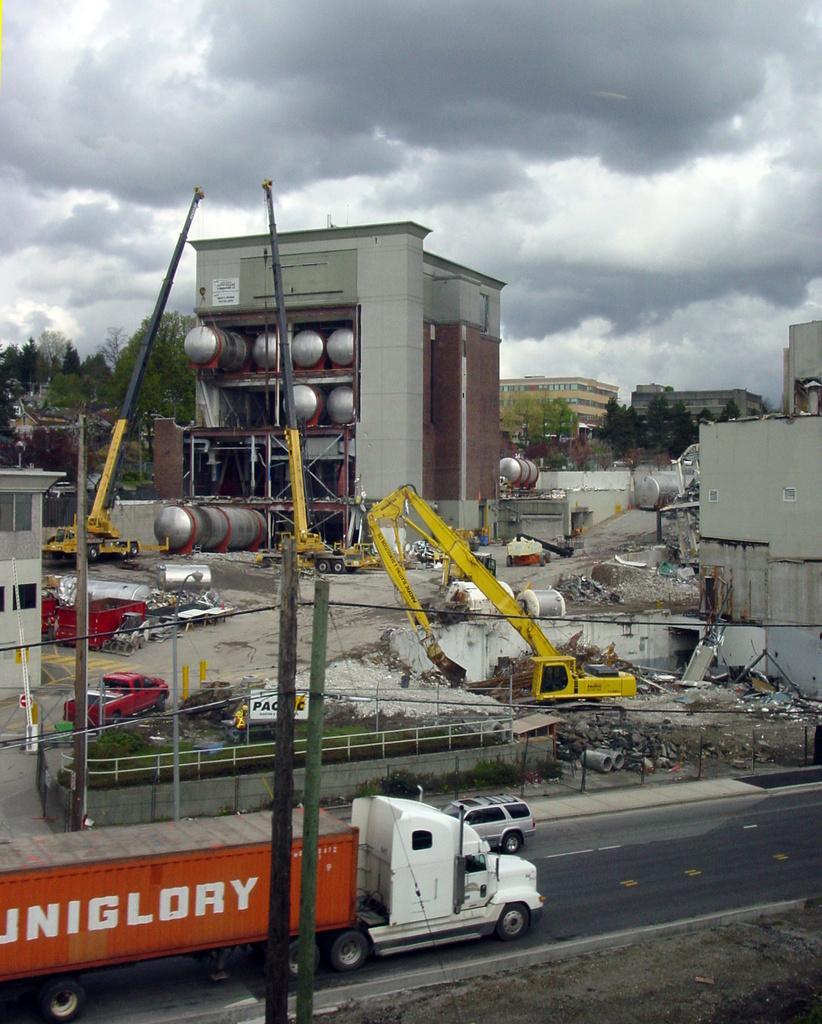Could you give a brief overview of what you see in this image? In this picture we can see poles, vehicles, cranes, buildings, fence, board, wires and plants. In the background of the image we can see trees, buildings and sky with clouds. 